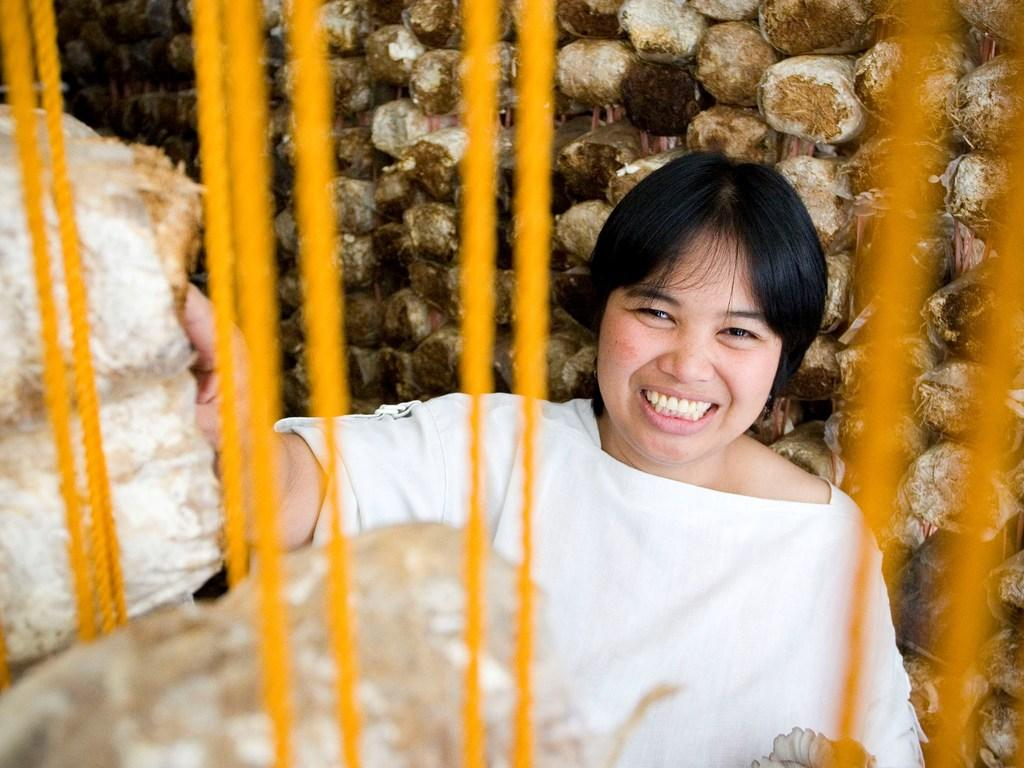Who is present in the image? There is a person in the image. What is the person's expression? The person is smiling. What is in front of the person? There are objects in front of the person. What type of material is used for the ropes in the image? The ropes in the image are made of a material that is not specified, but they are visible. What can be seen in the background of the image? There are wooden logs in the background of the image. What is the name of the person in the image? The name of the person in the image is not mentioned or visible, so it cannot be determined. 